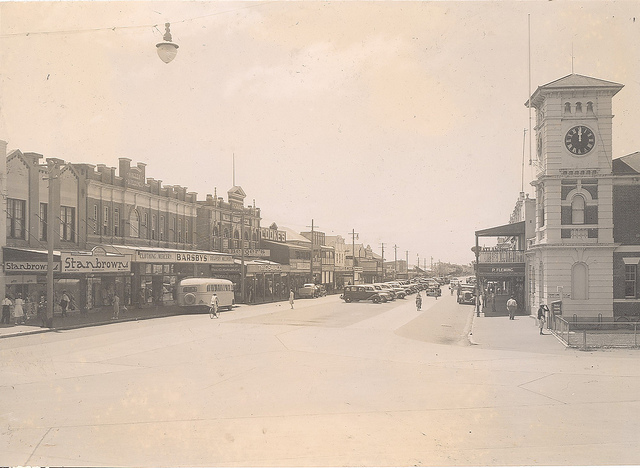Please transcribe the text in this image. BARSBYS Stanbrowns stanbrow 